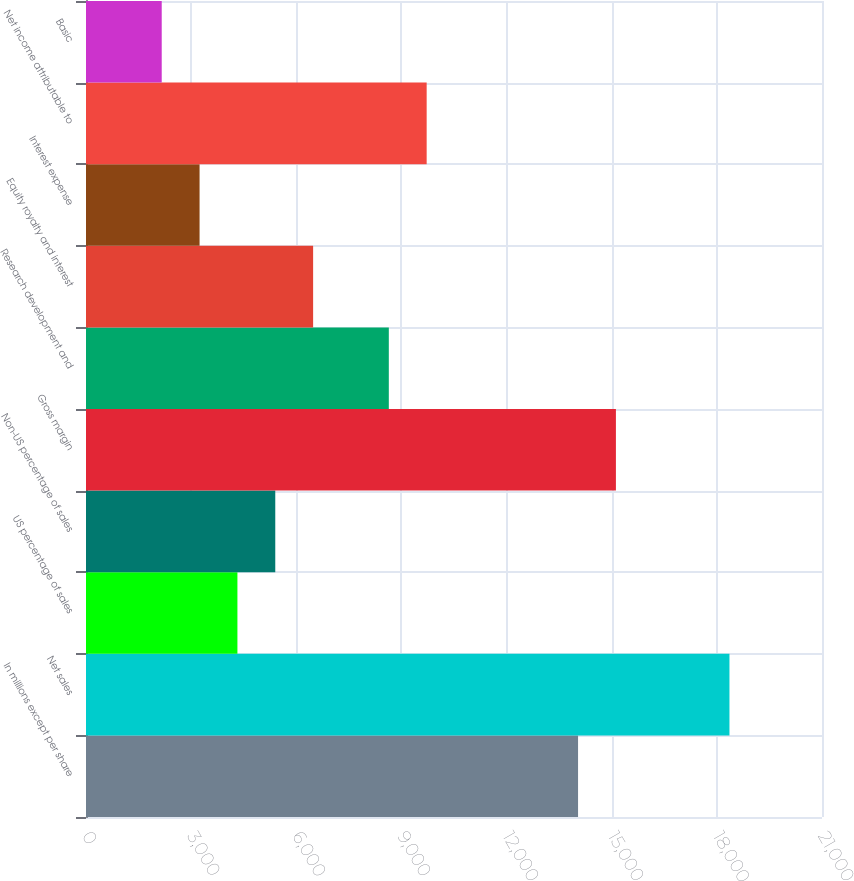Convert chart. <chart><loc_0><loc_0><loc_500><loc_500><bar_chart><fcel>In millions except per share<fcel>Net sales<fcel>US percentage of sales<fcel>Non-US percentage of sales<fcel>Gross margin<fcel>Research development and<fcel>Equity royalty and interest<fcel>Interest expense<fcel>Net income attributable to<fcel>Basic<nl><fcel>14039.8<fcel>18359.5<fcel>4320.42<fcel>5400.35<fcel>15119.7<fcel>8640.14<fcel>6480.28<fcel>3240.49<fcel>9720.07<fcel>2160.56<nl></chart> 